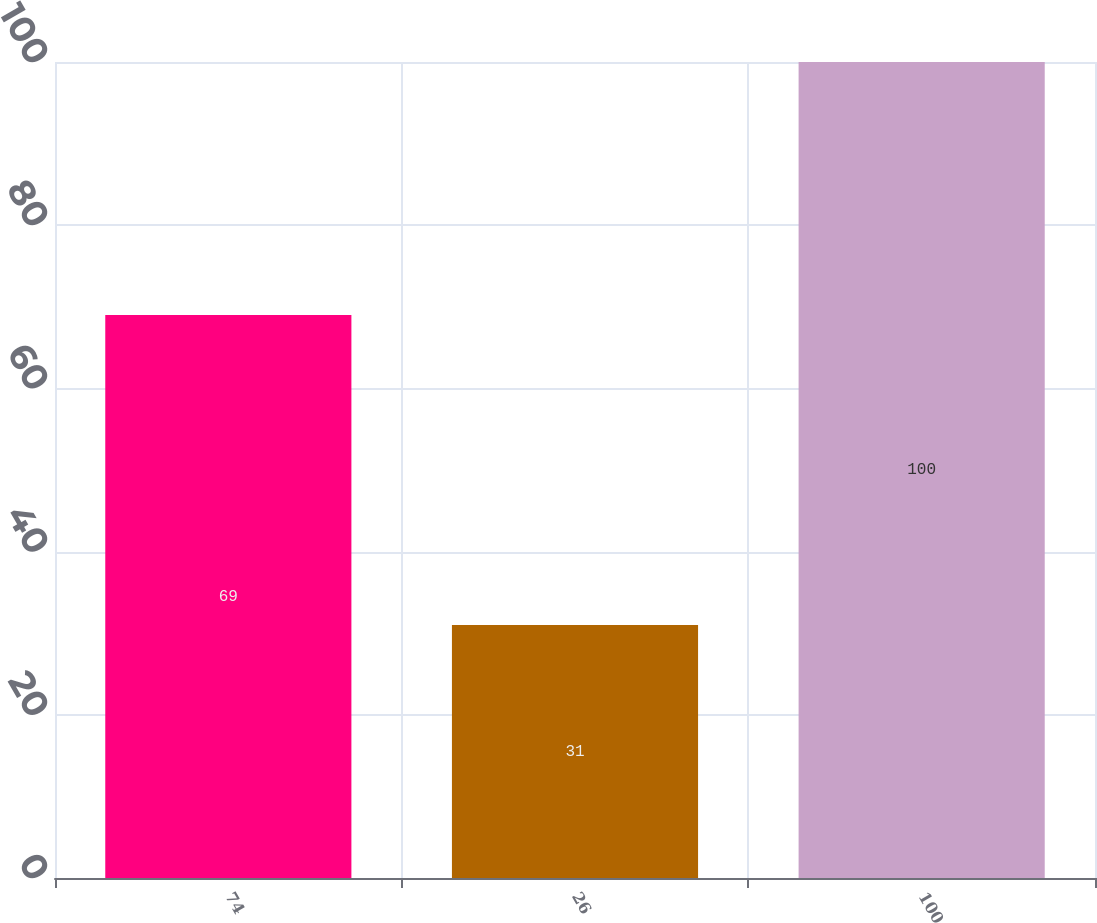Convert chart. <chart><loc_0><loc_0><loc_500><loc_500><bar_chart><fcel>74<fcel>26<fcel>100<nl><fcel>69<fcel>31<fcel>100<nl></chart> 